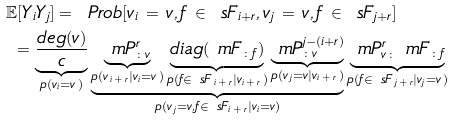Convert formula to latex. <formula><loc_0><loc_0><loc_500><loc_500>\mathbb { E } [ Y _ { i } Y _ { j } ] = \ & P r o b [ v _ { i } \, = \, v , f \, \in \, \ s F _ { i + r } , v _ { j } \, = \, v , f \, \in \, \ s F _ { j + r } ] \\ = \underbrace { \frac { d e g ( v ) } { c } } _ { p ( v _ { i } = v \, ) } & \underbrace { \underbrace { \ m P _ { \colon v } ^ { r } } _ { p ( v _ { \, i \, + \, r } | v _ { i } = v \, ) } \underbrace { d i a g ( \ m F _ { \colon f } ) } _ { p ( f \in \ s F _ { \, i \, + \, r } | v _ { i \, + \, r } \, ) } \underbrace { \ m P ^ { j - ( i + r ) } _ { \colon v } } _ { p ( v _ { \, j } = v | v _ { i \, + \, r } \, ) } } _ { p ( v _ { \, j } = v , f \in \ s F _ { i \, + \, r } | v _ { i } = v ) } \underbrace { \ m P ^ { r } _ { v \colon } \ m F _ { \colon f } } _ { p ( f \in \ s F _ { \, j \, + \, r } | v _ { j } = v \, ) }</formula> 